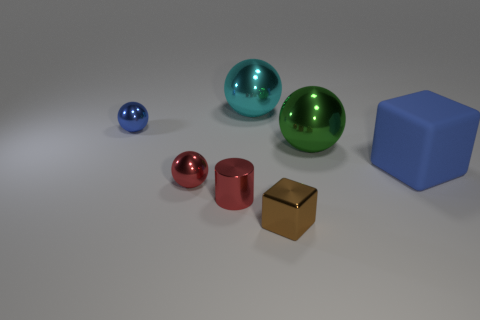Subtract all large cyan metal balls. How many balls are left? 3 Add 2 small green metallic balls. How many objects exist? 9 Subtract all green balls. How many balls are left? 3 Subtract 2 balls. How many balls are left? 2 Subtract all blocks. How many objects are left? 5 Add 4 cylinders. How many cylinders exist? 5 Subtract 0 cyan cubes. How many objects are left? 7 Subtract all purple cubes. Subtract all purple cylinders. How many cubes are left? 2 Subtract all big brown matte cylinders. Subtract all red objects. How many objects are left? 5 Add 6 big green metal things. How many big green metal things are left? 7 